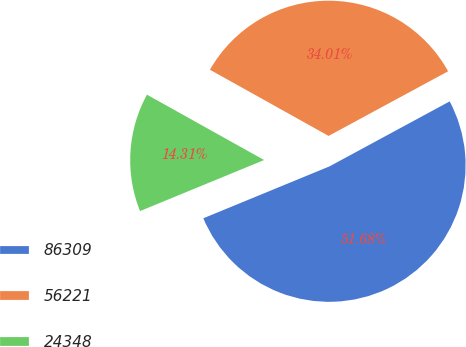<chart> <loc_0><loc_0><loc_500><loc_500><pie_chart><fcel>86309<fcel>56221<fcel>24348<nl><fcel>51.68%<fcel>34.01%<fcel>14.31%<nl></chart> 